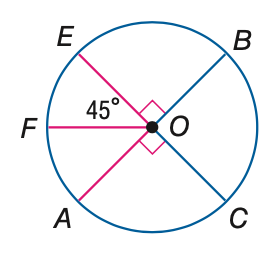Question: E C and A B are diameters of \odot O. Find its measure of \widehat E B.
Choices:
A. 45
B. 90
C. 180
D. 270
Answer with the letter. Answer: B Question: E C and A B are diameters of \odot O. Find its measure of \widehat A C E.
Choices:
A. 60
B. 90
C. 180
D. 270
Answer with the letter. Answer: D Question: E C and A B are diameters of \odot O. Find its measure of \widehat A C B.
Choices:
A. 45
B. 90
C. 180
D. 270
Answer with the letter. Answer: C 